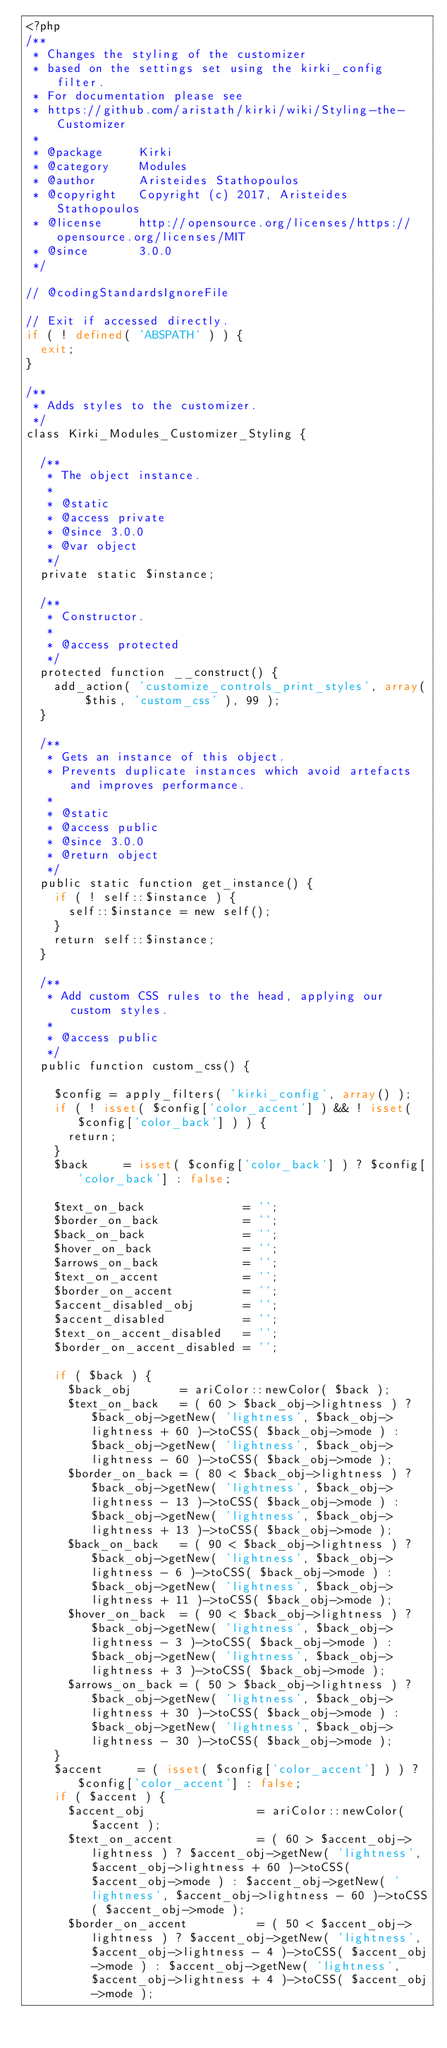<code> <loc_0><loc_0><loc_500><loc_500><_PHP_><?php
/**
 * Changes the styling of the customizer
 * based on the settings set using the kirki_config filter.
 * For documentation please see
 * https://github.com/aristath/kirki/wiki/Styling-the-Customizer
 *
 * @package     Kirki
 * @category    Modules
 * @author      Aristeides Stathopoulos
 * @copyright   Copyright (c) 2017, Aristeides Stathopoulos
 * @license     http://opensource.org/licenses/https://opensource.org/licenses/MIT
 * @since       3.0.0
 */

// @codingStandardsIgnoreFile

// Exit if accessed directly.
if ( ! defined( 'ABSPATH' ) ) {
	exit;
}

/**
 * Adds styles to the customizer.
 */
class Kirki_Modules_Customizer_Styling {

	/**
	 * The object instance.
	 *
	 * @static
	 * @access private
	 * @since 3.0.0
	 * @var object
	 */
	private static $instance;

	/**
	 * Constructor.
	 *
	 * @access protected
	 */
	protected function __construct() {
		add_action( 'customize_controls_print_styles', array( $this, 'custom_css' ), 99 );
	}

	/**
	 * Gets an instance of this object.
	 * Prevents duplicate instances which avoid artefacts and improves performance.
	 *
	 * @static
	 * @access public
	 * @since 3.0.0
	 * @return object
	 */
	public static function get_instance() {
		if ( ! self::$instance ) {
			self::$instance = new self();
		}
		return self::$instance;
	}

	/**
	 * Add custom CSS rules to the head, applying our custom styles.
	 *
	 * @access public
	 */
	public function custom_css() {

		$config = apply_filters( 'kirki_config', array() );
		if ( ! isset( $config['color_accent'] ) && ! isset( $config['color_back'] ) ) {
			return;
		}
		$back     = isset( $config['color_back'] ) ? $config['color_back'] : false;

		$text_on_back              = '';
		$border_on_back            = '';
		$back_on_back              = '';
		$hover_on_back             = '';
		$arrows_on_back            = '';
		$text_on_accent            = '';
		$border_on_accent          = '';
		$accent_disabled_obj       = '';
		$accent_disabled           = '';
		$text_on_accent_disabled   = '';
		$border_on_accent_disabled = '';

		if ( $back ) {
			$back_obj       = ariColor::newColor( $back );
			$text_on_back   = ( 60 > $back_obj->lightness ) ? $back_obj->getNew( 'lightness', $back_obj->lightness + 60 )->toCSS( $back_obj->mode ) : $back_obj->getNew( 'lightness', $back_obj->lightness - 60 )->toCSS( $back_obj->mode );
			$border_on_back = ( 80 < $back_obj->lightness ) ? $back_obj->getNew( 'lightness', $back_obj->lightness - 13 )->toCSS( $back_obj->mode ) : $back_obj->getNew( 'lightness', $back_obj->lightness + 13 )->toCSS( $back_obj->mode );
			$back_on_back   = ( 90 < $back_obj->lightness ) ? $back_obj->getNew( 'lightness', $back_obj->lightness - 6 )->toCSS( $back_obj->mode ) : $back_obj->getNew( 'lightness', $back_obj->lightness + 11 )->toCSS( $back_obj->mode );
			$hover_on_back  = ( 90 < $back_obj->lightness ) ? $back_obj->getNew( 'lightness', $back_obj->lightness - 3 )->toCSS( $back_obj->mode ) : $back_obj->getNew( 'lightness', $back_obj->lightness + 3 )->toCSS( $back_obj->mode );
			$arrows_on_back = ( 50 > $back_obj->lightness ) ? $back_obj->getNew( 'lightness', $back_obj->lightness + 30 )->toCSS( $back_obj->mode ) : $back_obj->getNew( 'lightness', $back_obj->lightness - 30 )->toCSS( $back_obj->mode );
		}
		$accent     = ( isset( $config['color_accent'] ) ) ? $config['color_accent'] : false;
		if ( $accent ) {
			$accent_obj                = ariColor::newColor( $accent );
			$text_on_accent            = ( 60 > $accent_obj->lightness ) ? $accent_obj->getNew( 'lightness', $accent_obj->lightness + 60 )->toCSS( $accent_obj->mode ) : $accent_obj->getNew( 'lightness', $accent_obj->lightness - 60 )->toCSS( $accent_obj->mode );
			$border_on_accent          = ( 50 < $accent_obj->lightness ) ? $accent_obj->getNew( 'lightness', $accent_obj->lightness - 4 )->toCSS( $accent_obj->mode ) : $accent_obj->getNew( 'lightness', $accent_obj->lightness + 4 )->toCSS( $accent_obj->mode );</code> 